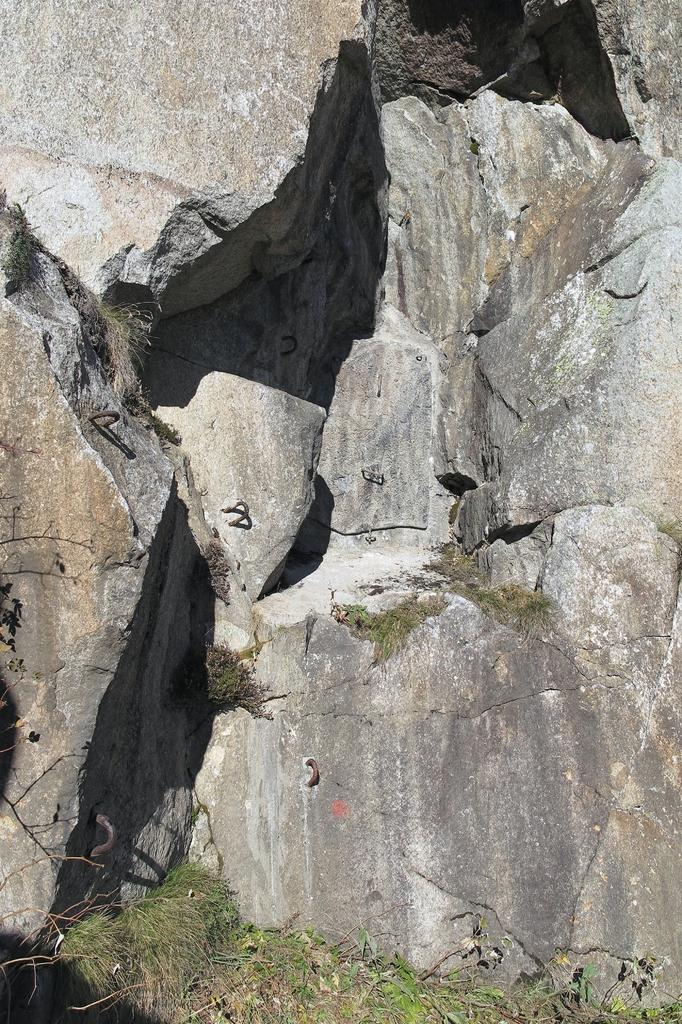What type of terrain is visible in the image? There is a rock hill in the image. What type of vegetation is present in front of the rock hill? There is grass in front of the rock hill. What type of lettuce is used in the design of the rock hill in the image? There is no lettuce present in the image, and the rock hill is not a design element. 